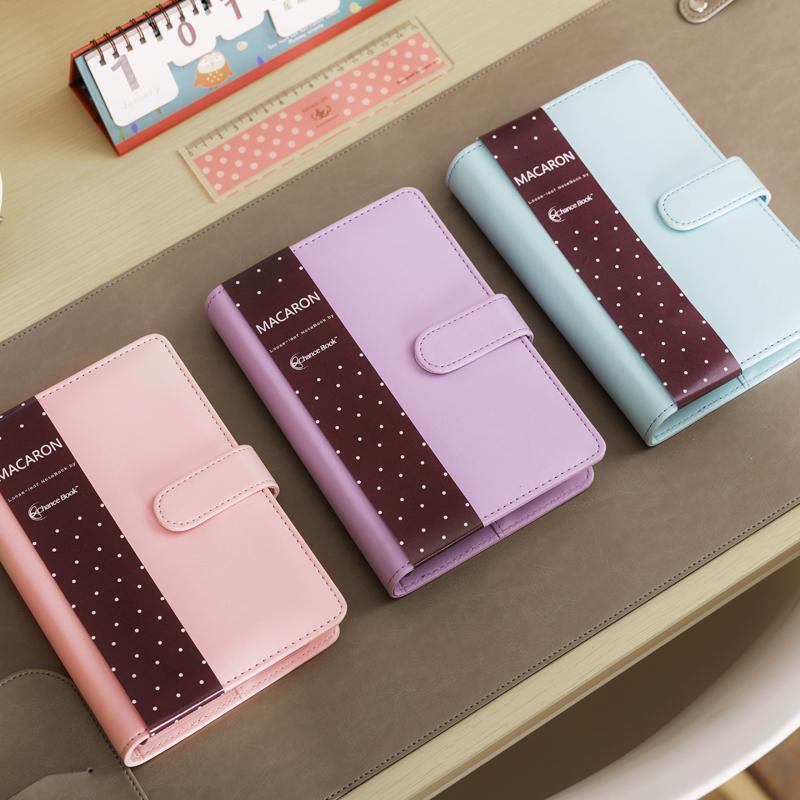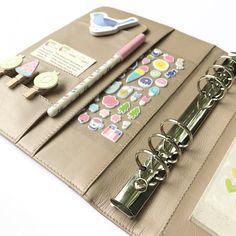The first image is the image on the left, the second image is the image on the right. For the images shown, is this caption "One of the binders is gold." true? Answer yes or no. Yes. 